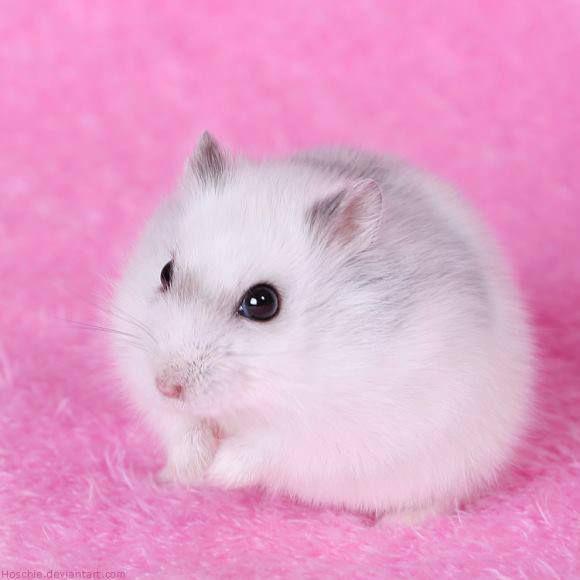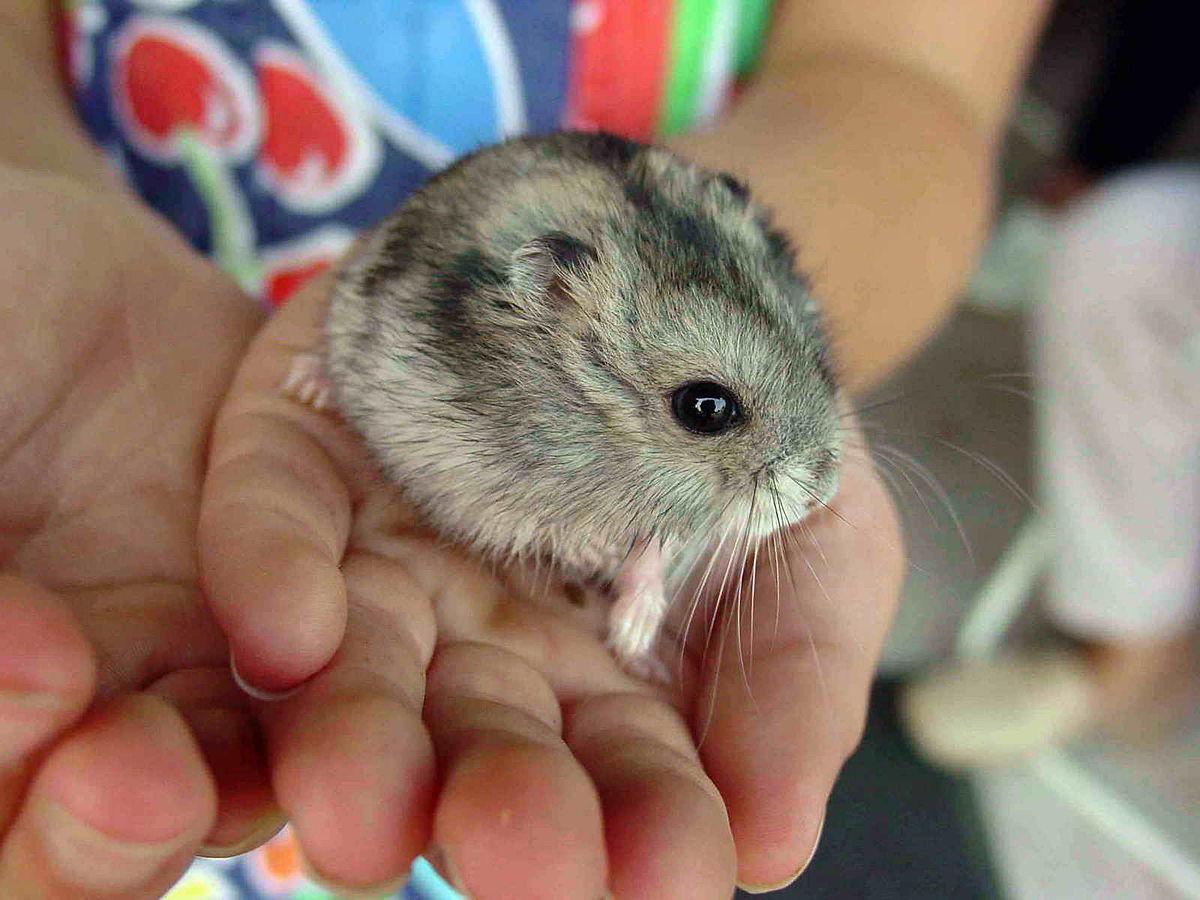The first image is the image on the left, the second image is the image on the right. Evaluate the accuracy of this statement regarding the images: "One of the images has a plain white background.". Is it true? Answer yes or no. No. 